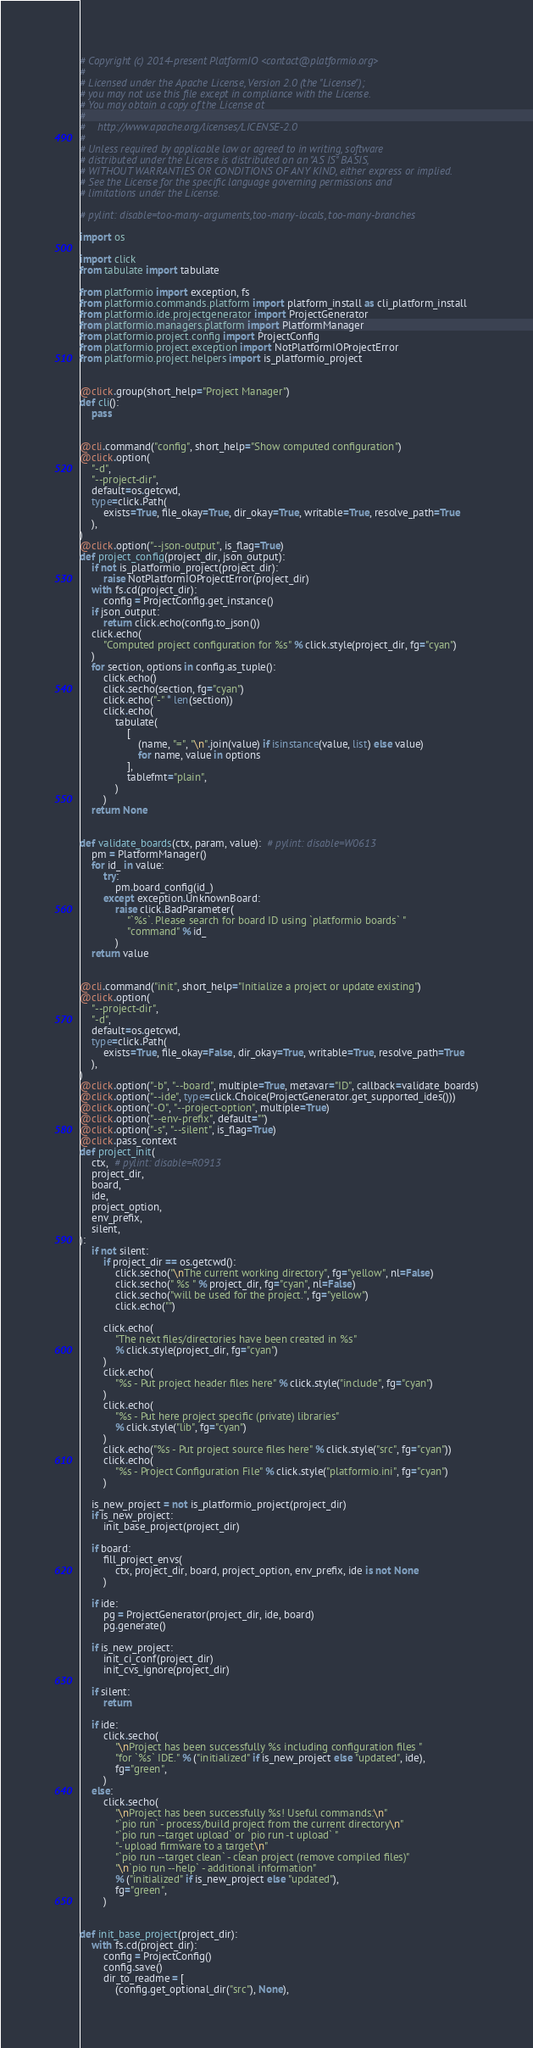Convert code to text. <code><loc_0><loc_0><loc_500><loc_500><_Python_># Copyright (c) 2014-present PlatformIO <contact@platformio.org>
#
# Licensed under the Apache License, Version 2.0 (the "License");
# you may not use this file except in compliance with the License.
# You may obtain a copy of the License at
#
#    http://www.apache.org/licenses/LICENSE-2.0
#
# Unless required by applicable law or agreed to in writing, software
# distributed under the License is distributed on an "AS IS" BASIS,
# WITHOUT WARRANTIES OR CONDITIONS OF ANY KIND, either express or implied.
# See the License for the specific language governing permissions and
# limitations under the License.

# pylint: disable=too-many-arguments,too-many-locals, too-many-branches

import os

import click
from tabulate import tabulate

from platformio import exception, fs
from platformio.commands.platform import platform_install as cli_platform_install
from platformio.ide.projectgenerator import ProjectGenerator
from platformio.managers.platform import PlatformManager
from platformio.project.config import ProjectConfig
from platformio.project.exception import NotPlatformIOProjectError
from platformio.project.helpers import is_platformio_project


@click.group(short_help="Project Manager")
def cli():
    pass


@cli.command("config", short_help="Show computed configuration")
@click.option(
    "-d",
    "--project-dir",
    default=os.getcwd,
    type=click.Path(
        exists=True, file_okay=True, dir_okay=True, writable=True, resolve_path=True
    ),
)
@click.option("--json-output", is_flag=True)
def project_config(project_dir, json_output):
    if not is_platformio_project(project_dir):
        raise NotPlatformIOProjectError(project_dir)
    with fs.cd(project_dir):
        config = ProjectConfig.get_instance()
    if json_output:
        return click.echo(config.to_json())
    click.echo(
        "Computed project configuration for %s" % click.style(project_dir, fg="cyan")
    )
    for section, options in config.as_tuple():
        click.echo()
        click.secho(section, fg="cyan")
        click.echo("-" * len(section))
        click.echo(
            tabulate(
                [
                    (name, "=", "\n".join(value) if isinstance(value, list) else value)
                    for name, value in options
                ],
                tablefmt="plain",
            )
        )
    return None


def validate_boards(ctx, param, value):  # pylint: disable=W0613
    pm = PlatformManager()
    for id_ in value:
        try:
            pm.board_config(id_)
        except exception.UnknownBoard:
            raise click.BadParameter(
                "`%s`. Please search for board ID using `platformio boards` "
                "command" % id_
            )
    return value


@cli.command("init", short_help="Initialize a project or update existing")
@click.option(
    "--project-dir",
    "-d",
    default=os.getcwd,
    type=click.Path(
        exists=True, file_okay=False, dir_okay=True, writable=True, resolve_path=True
    ),
)
@click.option("-b", "--board", multiple=True, metavar="ID", callback=validate_boards)
@click.option("--ide", type=click.Choice(ProjectGenerator.get_supported_ides()))
@click.option("-O", "--project-option", multiple=True)
@click.option("--env-prefix", default="")
@click.option("-s", "--silent", is_flag=True)
@click.pass_context
def project_init(
    ctx,  # pylint: disable=R0913
    project_dir,
    board,
    ide,
    project_option,
    env_prefix,
    silent,
):
    if not silent:
        if project_dir == os.getcwd():
            click.secho("\nThe current working directory", fg="yellow", nl=False)
            click.secho(" %s " % project_dir, fg="cyan", nl=False)
            click.secho("will be used for the project.", fg="yellow")
            click.echo("")

        click.echo(
            "The next files/directories have been created in %s"
            % click.style(project_dir, fg="cyan")
        )
        click.echo(
            "%s - Put project header files here" % click.style("include", fg="cyan")
        )
        click.echo(
            "%s - Put here project specific (private) libraries"
            % click.style("lib", fg="cyan")
        )
        click.echo("%s - Put project source files here" % click.style("src", fg="cyan"))
        click.echo(
            "%s - Project Configuration File" % click.style("platformio.ini", fg="cyan")
        )

    is_new_project = not is_platformio_project(project_dir)
    if is_new_project:
        init_base_project(project_dir)

    if board:
        fill_project_envs(
            ctx, project_dir, board, project_option, env_prefix, ide is not None
        )

    if ide:
        pg = ProjectGenerator(project_dir, ide, board)
        pg.generate()

    if is_new_project:
        init_ci_conf(project_dir)
        init_cvs_ignore(project_dir)

    if silent:
        return

    if ide:
        click.secho(
            "\nProject has been successfully %s including configuration files "
            "for `%s` IDE." % ("initialized" if is_new_project else "updated", ide),
            fg="green",
        )
    else:
        click.secho(
            "\nProject has been successfully %s! Useful commands:\n"
            "`pio run` - process/build project from the current directory\n"
            "`pio run --target upload` or `pio run -t upload` "
            "- upload firmware to a target\n"
            "`pio run --target clean` - clean project (remove compiled files)"
            "\n`pio run --help` - additional information"
            % ("initialized" if is_new_project else "updated"),
            fg="green",
        )


def init_base_project(project_dir):
    with fs.cd(project_dir):
        config = ProjectConfig()
        config.save()
        dir_to_readme = [
            (config.get_optional_dir("src"), None),</code> 